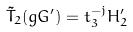Convert formula to latex. <formula><loc_0><loc_0><loc_500><loc_500>\tilde { T } _ { 2 } ( g G ^ { \prime } ) = t _ { 3 } ^ { - j } H _ { 2 } ^ { \prime }</formula> 